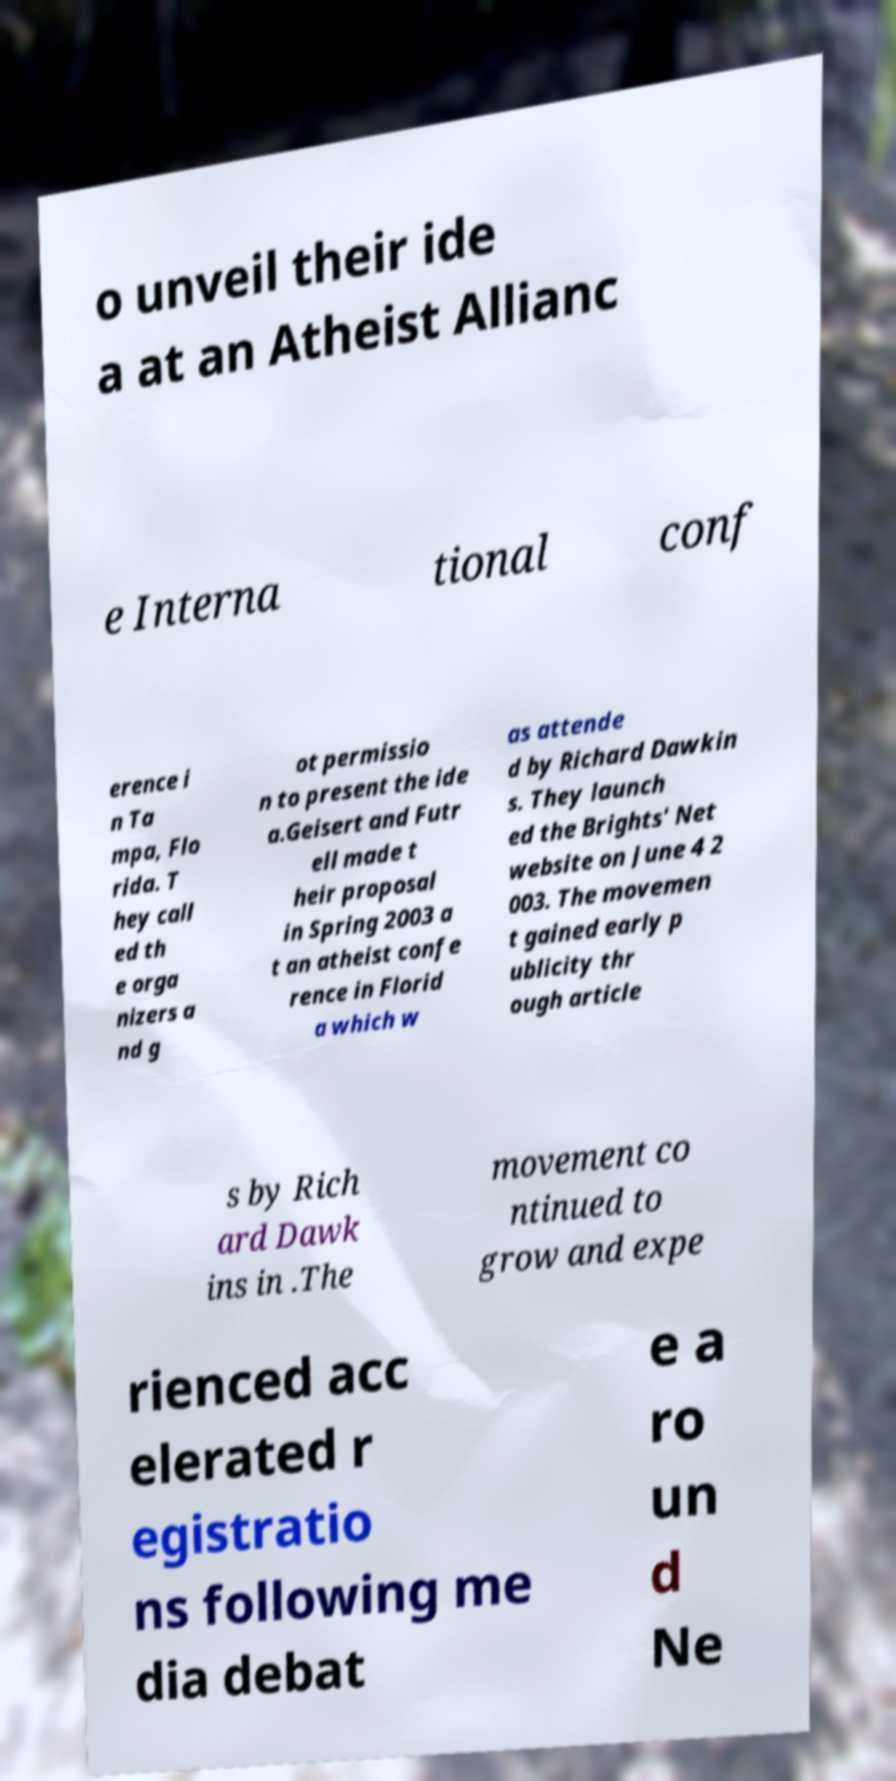For documentation purposes, I need the text within this image transcribed. Could you provide that? o unveil their ide a at an Atheist Allianc e Interna tional conf erence i n Ta mpa, Flo rida. T hey call ed th e orga nizers a nd g ot permissio n to present the ide a.Geisert and Futr ell made t heir proposal in Spring 2003 a t an atheist confe rence in Florid a which w as attende d by Richard Dawkin s. They launch ed the Brights' Net website on June 4 2 003. The movemen t gained early p ublicity thr ough article s by Rich ard Dawk ins in .The movement co ntinued to grow and expe rienced acc elerated r egistratio ns following me dia debat e a ro un d Ne 